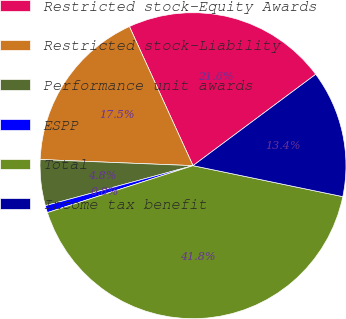<chart> <loc_0><loc_0><loc_500><loc_500><pie_chart><fcel>Restricted stock-Equity Awards<fcel>Restricted stock-Liability<fcel>Performance unit awards<fcel>ESPP<fcel>Total<fcel>Income tax benefit<nl><fcel>21.64%<fcel>17.54%<fcel>4.85%<fcel>0.75%<fcel>41.79%<fcel>13.43%<nl></chart> 